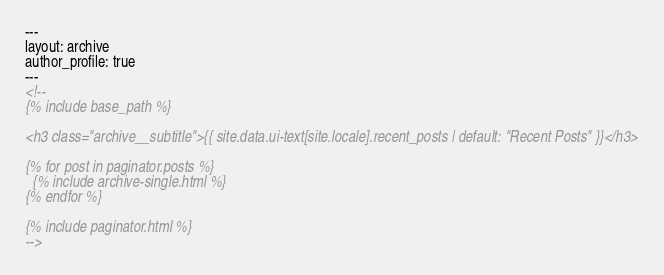Convert code to text. <code><loc_0><loc_0><loc_500><loc_500><_HTML_>---
layout: archive
author_profile: true
---
<!--
{% include base_path %}

<h3 class="archive__subtitle">{{ site.data.ui-text[site.locale].recent_posts | default: "Recent Posts" }}</h3>

{% for post in paginator.posts %}
  {% include archive-single.html %}
{% endfor %}

{% include paginator.html %}
-->
</code> 